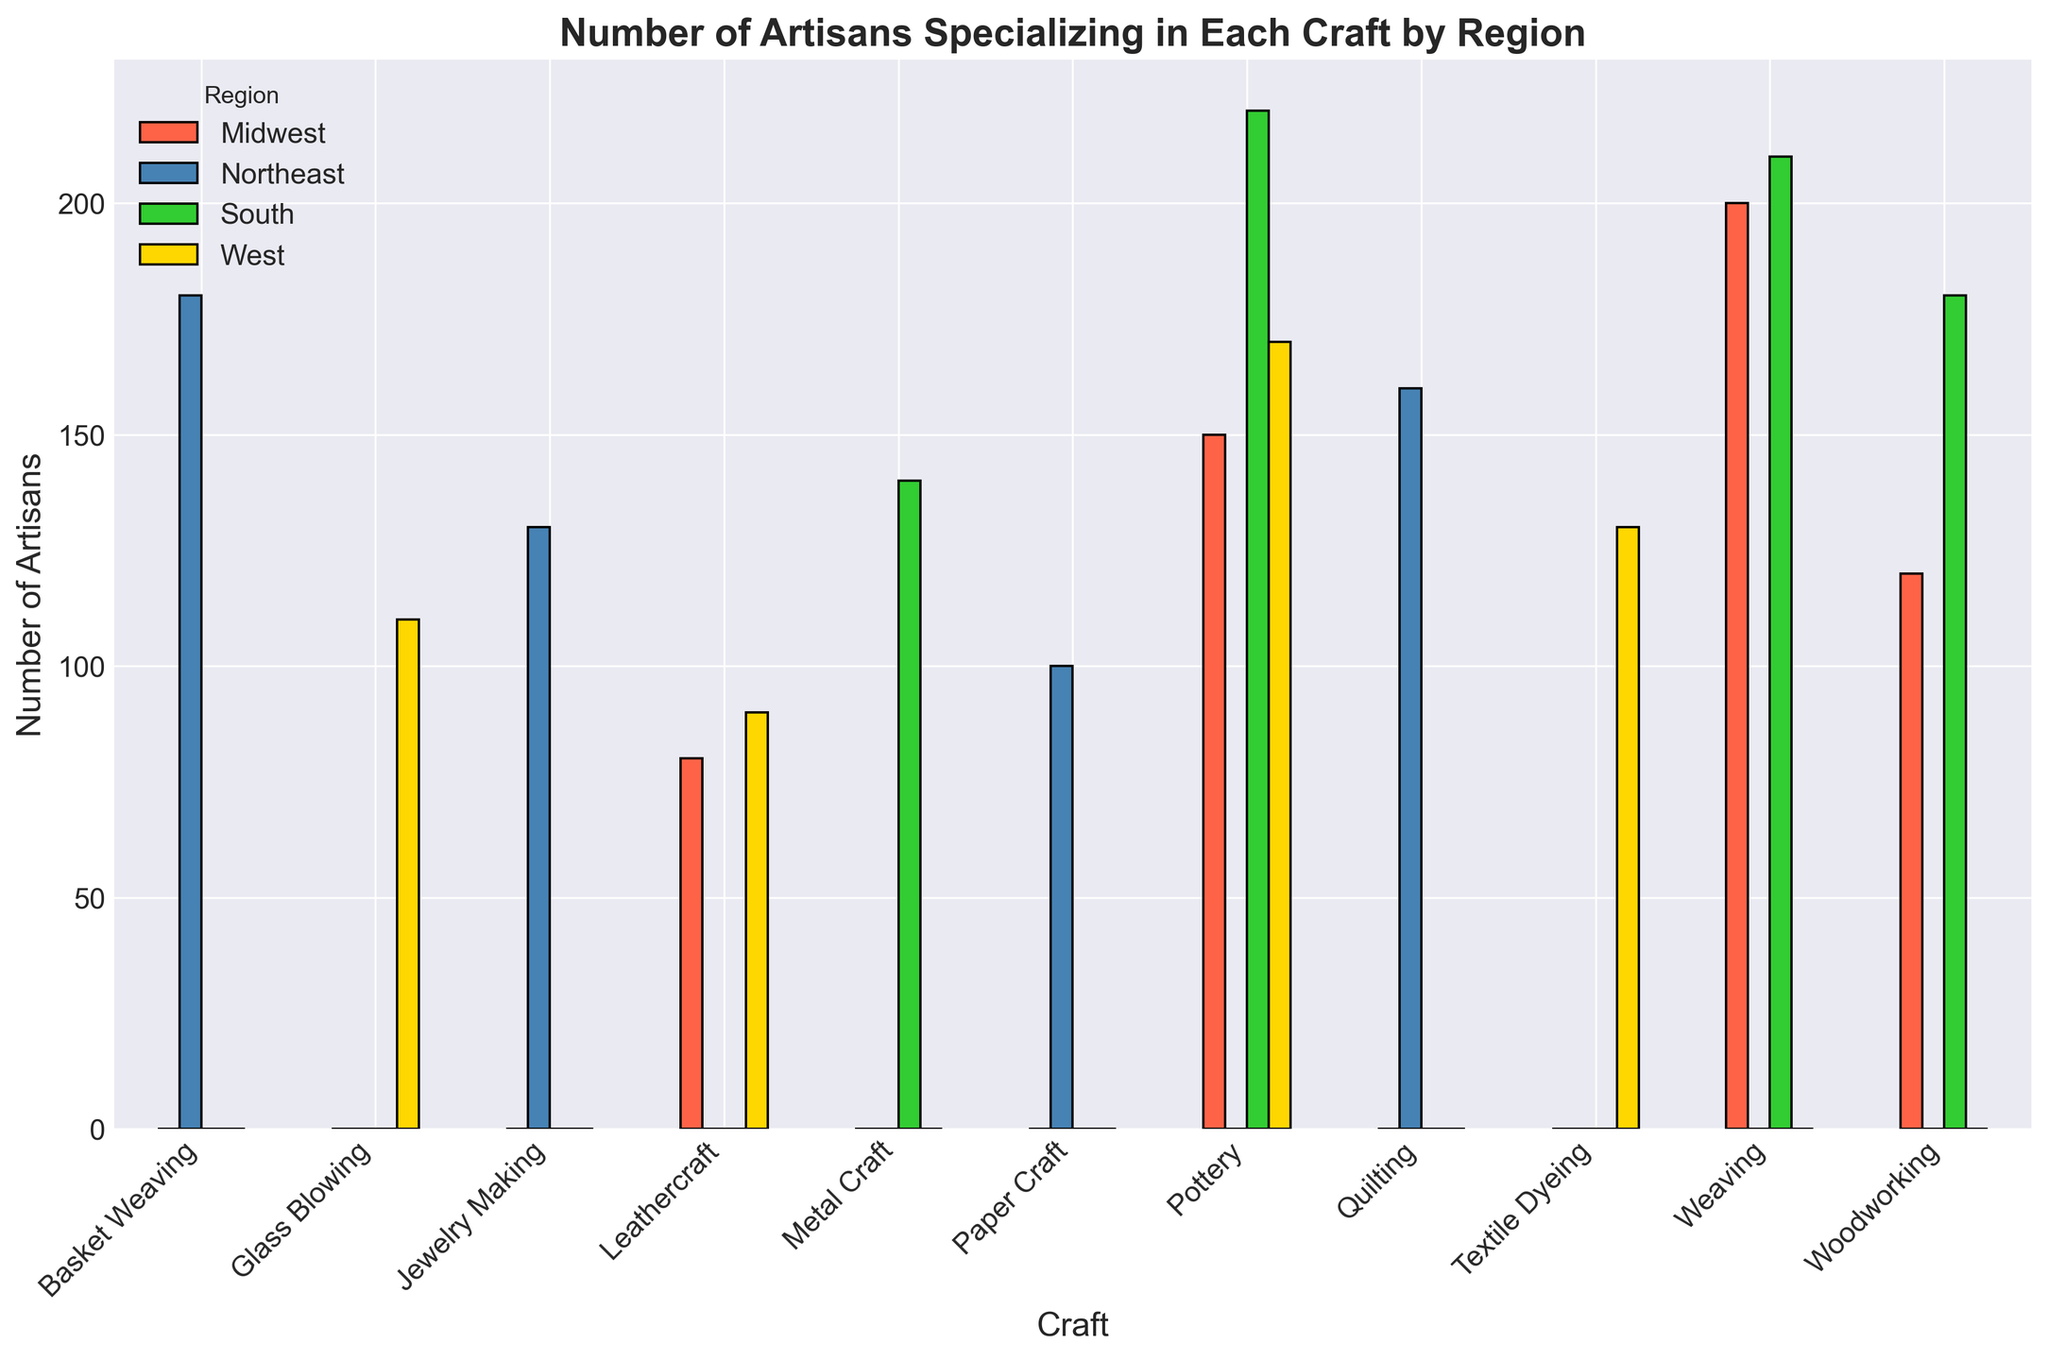Which craft has the highest number of artisans in the Midwest? The chart shows that 'Weaving' has the highest bar in the Midwest category. The height of the bar for weaving is 200 artisans.
Answer: Weaving Which region has the most artisans specializing in Pottery? To answer, compare the heights of the bars for Pottery across all regions. The South has the tallest bar for Pottery with 220 artisans.
Answer: South What is the total number of artisans specializing in Weaving across all regions? Add the number of artisans in Weaving from each region: Midwest (200) and South (210). Sum = 200 + 210 = 410 artisans.
Answer: 410 Which region has the fewest artisans in any craft, and what is that craft? Look for the shortest bar in the entire chart. This is Leathercraft in the Midwest with 80 artisans.
Answer: Midwest, Leathercraft How many more artisans specialize in Quilting compared to Paper Craft in the Northeast? Find the number of artisans in Quilting (160) and in Paper Craft (100). Subtract the smaller number from the larger number: 160 - 100 = 60 artisans.
Answer: 60 What is the average number of artisans specializing in Woodworking across the regions? Add the number of artisans in Woodworking from Midwest (120) and South (180). There are two regions with Woodworking, so average = (120 + 180) / 2 = 150 artisans.
Answer: 150 Which craft has artisans in only one region, and which region is it? Analyze the chart for crafts with bars in only one region. 'Glass Blowing' is only present in the West with 110 artisans.
Answer: Glass Blowing, West Which region has a higher number of artisans in Leathercraft, Midwest or West? Compare the bar heights for Leathercraft in the Midwest (80) and West (90). The West has the higher number of artisans.
Answer: West What is the difference in the total number of artisans between Pottery and Metal Craft in the South? Find the number of artisans in Pottery (220) and Metal Craft (140) in the South. Subtract the number of artisans in Metal Craft from Pottery: 220 - 140 = 80 artisans.
Answer: 80 What is the combined total number of artisans for all crafts in the Northeast? Add the number of artisans for each craft in the Northeast: Basket Weaving (180), Jewelry Making (130), Quilting (160), Paper Craft (100). Total = 180 + 130 + 160 + 100 = 570 artisans.
Answer: 570 